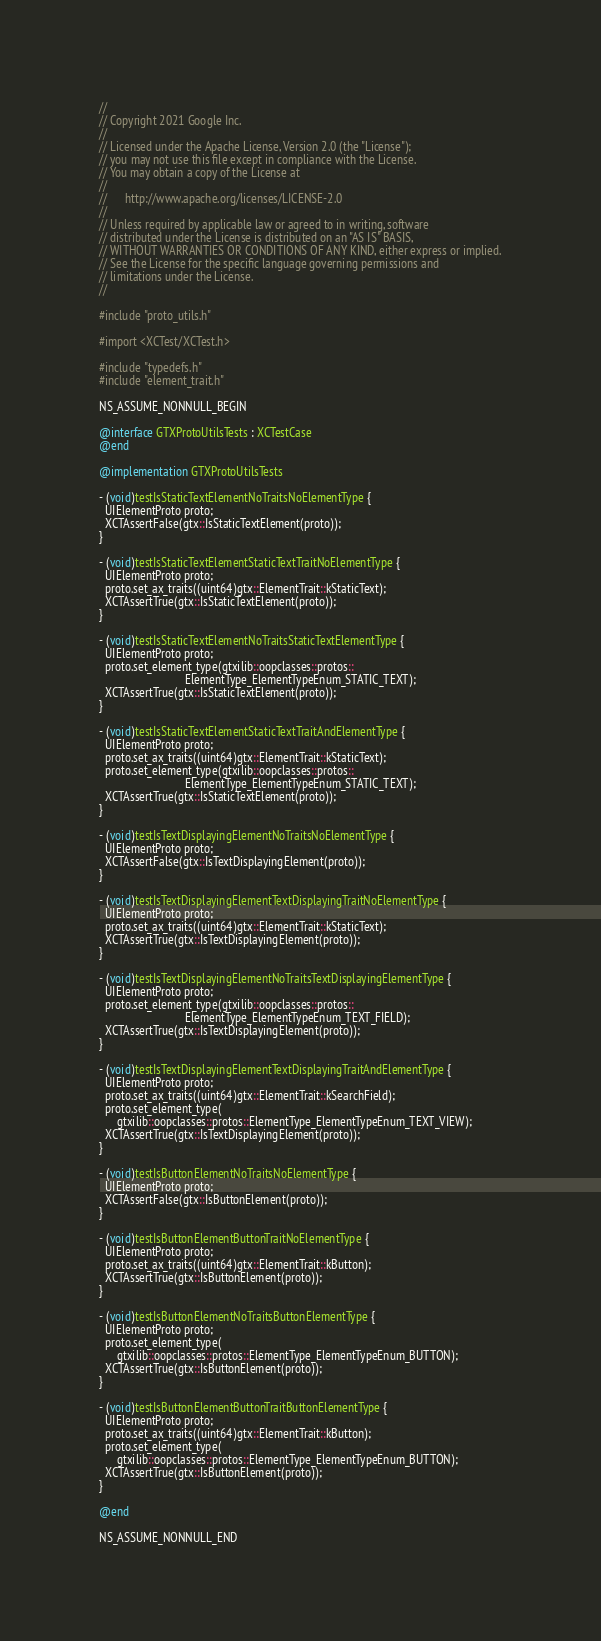Convert code to text. <code><loc_0><loc_0><loc_500><loc_500><_ObjectiveC_>//
// Copyright 2021 Google Inc.
//
// Licensed under the Apache License, Version 2.0 (the "License");
// you may not use this file except in compliance with the License.
// You may obtain a copy of the License at
//
//      http://www.apache.org/licenses/LICENSE-2.0
//
// Unless required by applicable law or agreed to in writing, software
// distributed under the License is distributed on an "AS IS" BASIS,
// WITHOUT WARRANTIES OR CONDITIONS OF ANY KIND, either express or implied.
// See the License for the specific language governing permissions and
// limitations under the License.
//

#include "proto_utils.h"

#import <XCTest/XCTest.h>

#include "typedefs.h"
#include "element_trait.h"

NS_ASSUME_NONNULL_BEGIN

@interface GTXProtoUtilsTests : XCTestCase
@end

@implementation GTXProtoUtilsTests

- (void)testIsStaticTextElementNoTraitsNoElementType {
  UIElementProto proto;
  XCTAssertFalse(gtx::IsStaticTextElement(proto));
}

- (void)testIsStaticTextElementStaticTextTraitNoElementType {
  UIElementProto proto;
  proto.set_ax_traits((uint64)gtx::ElementTrait::kStaticText);
  XCTAssertTrue(gtx::IsStaticTextElement(proto));
}

- (void)testIsStaticTextElementNoTraitsStaticTextElementType {
  UIElementProto proto;
  proto.set_element_type(gtxilib::oopclasses::protos::
                             ElementType_ElementTypeEnum_STATIC_TEXT);
  XCTAssertTrue(gtx::IsStaticTextElement(proto));
}

- (void)testIsStaticTextElementStaticTextTraitAndElementType {
  UIElementProto proto;
  proto.set_ax_traits((uint64)gtx::ElementTrait::kStaticText);
  proto.set_element_type(gtxilib::oopclasses::protos::
                             ElementType_ElementTypeEnum_STATIC_TEXT);
  XCTAssertTrue(gtx::IsStaticTextElement(proto));
}

- (void)testIsTextDisplayingElementNoTraitsNoElementType {
  UIElementProto proto;
  XCTAssertFalse(gtx::IsTextDisplayingElement(proto));
}

- (void)testIsTextDisplayingElementTextDisplayingTraitNoElementType {
  UIElementProto proto;
  proto.set_ax_traits((uint64)gtx::ElementTrait::kStaticText);
  XCTAssertTrue(gtx::IsTextDisplayingElement(proto));
}

- (void)testIsTextDisplayingElementNoTraitsTextDisplayingElementType {
  UIElementProto proto;
  proto.set_element_type(gtxilib::oopclasses::protos::
                             ElementType_ElementTypeEnum_TEXT_FIELD);
  XCTAssertTrue(gtx::IsTextDisplayingElement(proto));
}

- (void)testIsTextDisplayingElementTextDisplayingTraitAndElementType {
  UIElementProto proto;
  proto.set_ax_traits((uint64)gtx::ElementTrait::kSearchField);
  proto.set_element_type(
      gtxilib::oopclasses::protos::ElementType_ElementTypeEnum_TEXT_VIEW);
  XCTAssertTrue(gtx::IsTextDisplayingElement(proto));
}

- (void)testIsButtonElementNoTraitsNoElementType {
  UIElementProto proto;
  XCTAssertFalse(gtx::IsButtonElement(proto));
}

- (void)testIsButtonElementButtonTraitNoElementType {
  UIElementProto proto;
  proto.set_ax_traits((uint64)gtx::ElementTrait::kButton);
  XCTAssertTrue(gtx::IsButtonElement(proto));
}

- (void)testIsButtonElementNoTraitsButtonElementType {
  UIElementProto proto;
  proto.set_element_type(
      gtxilib::oopclasses::protos::ElementType_ElementTypeEnum_BUTTON);
  XCTAssertTrue(gtx::IsButtonElement(proto));
}

- (void)testIsButtonElementButtonTraitButtonElementType {
  UIElementProto proto;
  proto.set_ax_traits((uint64)gtx::ElementTrait::kButton);
  proto.set_element_type(
      gtxilib::oopclasses::protos::ElementType_ElementTypeEnum_BUTTON);
  XCTAssertTrue(gtx::IsButtonElement(proto));
}

@end

NS_ASSUME_NONNULL_END
</code> 